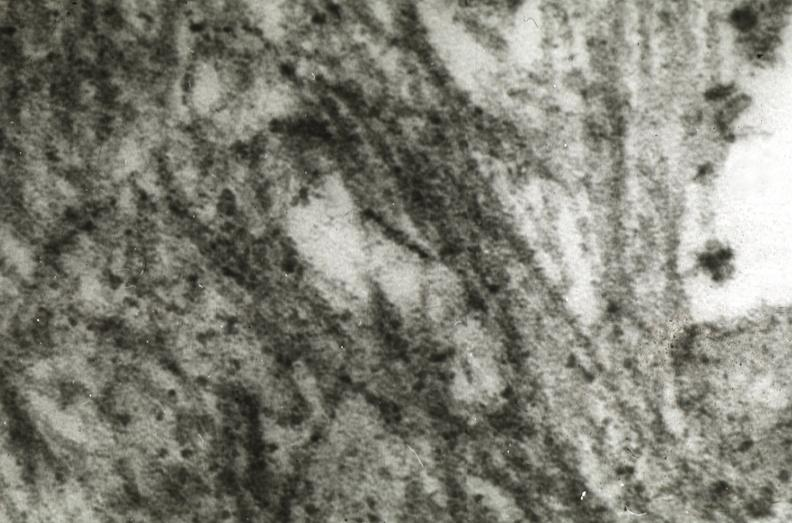s this photo of infant from head to toe present?
Answer the question using a single word or phrase. No 